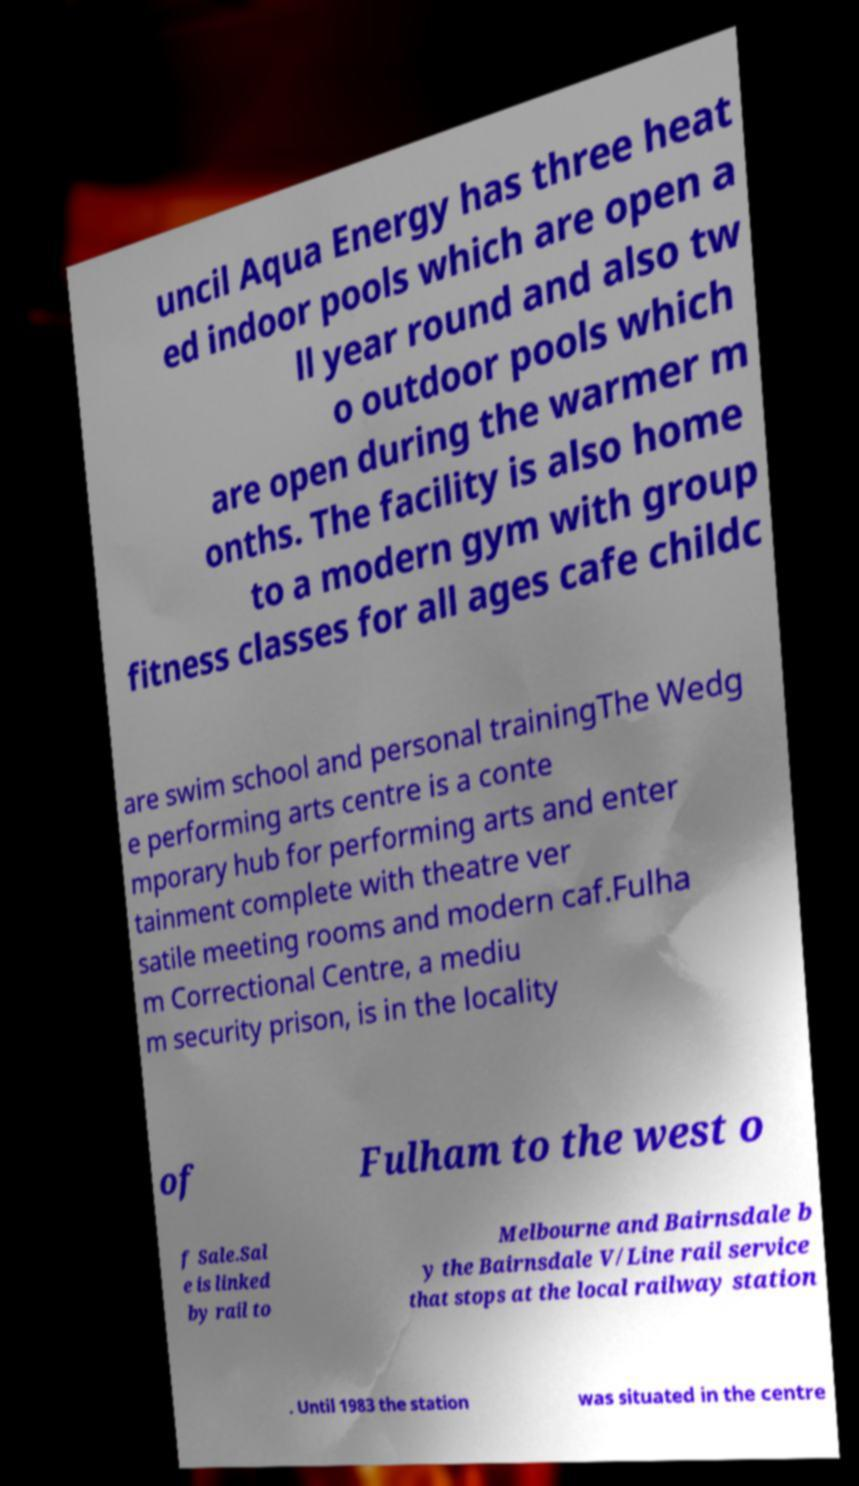Please read and relay the text visible in this image. What does it say? uncil Aqua Energy has three heat ed indoor pools which are open a ll year round and also tw o outdoor pools which are open during the warmer m onths. The facility is also home to a modern gym with group fitness classes for all ages cafe childc are swim school and personal trainingThe Wedg e performing arts centre is a conte mporary hub for performing arts and enter tainment complete with theatre ver satile meeting rooms and modern caf.Fulha m Correctional Centre, a mediu m security prison, is in the locality of Fulham to the west o f Sale.Sal e is linked by rail to Melbourne and Bairnsdale b y the Bairnsdale V/Line rail service that stops at the local railway station . Until 1983 the station was situated in the centre 